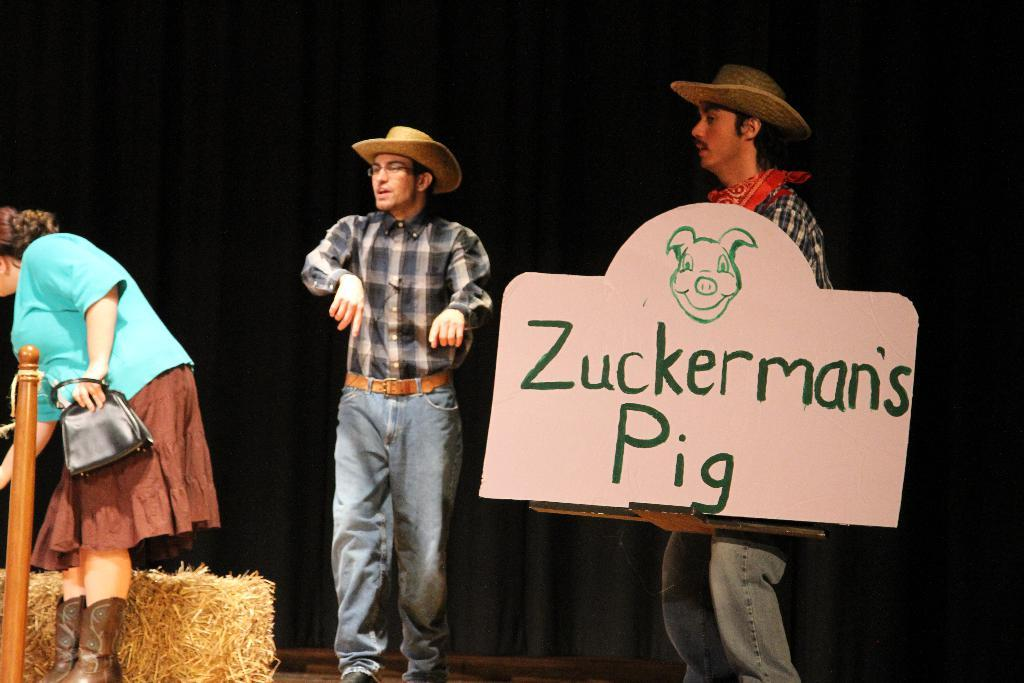How many people are in the image? There are two men and a woman in the image. What is the woman holding in the image? The woman is holding a bag. What is one of the men holding in the image? One of the men is holding a board in his hand. What can be seen in the background of the image? There is a black curtain in the background of the image. What is the argument about between the two men in the image? There is no argument depicted in the image; it only shows two men and a woman with the woman holding a bag and one of the men holding a board. 